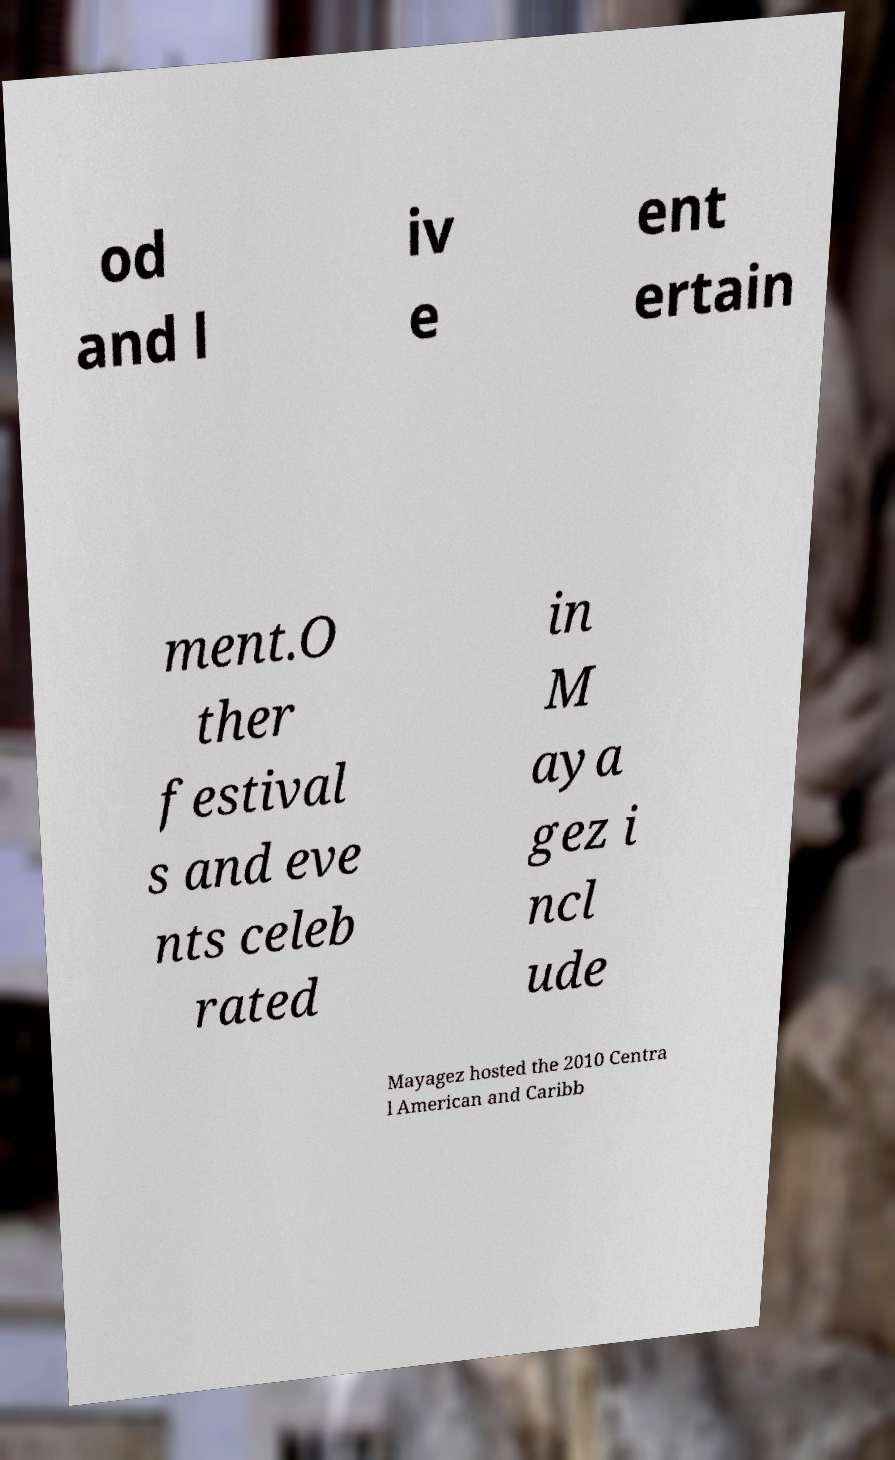Please identify and transcribe the text found in this image. od and l iv e ent ertain ment.O ther festival s and eve nts celeb rated in M aya gez i ncl ude Mayagez hosted the 2010 Centra l American and Caribb 